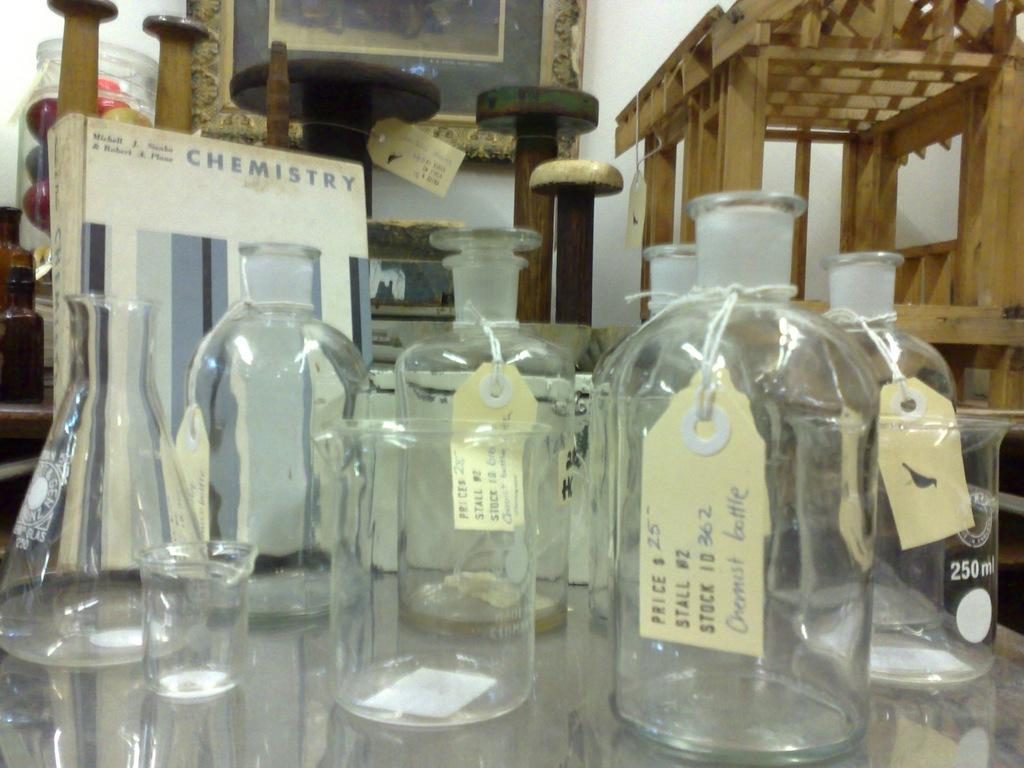Provide a one-sentence caption for the provided image. Glass bottles with price tags are displayed and the front bottle is priced a $25.00. 